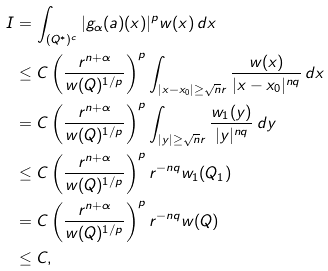<formula> <loc_0><loc_0><loc_500><loc_500>I & = \int _ { ( Q ^ { * } ) ^ { c } } | g _ { \alpha } ( a ) ( x ) | ^ { p } w ( x ) \, d x \\ & \leq C \left ( \frac { r ^ { n + \alpha } } { w ( Q ) ^ { 1 / p } } \right ) ^ { p } \int _ { | x - x _ { 0 } | \geq \sqrt { n } r } \frac { w ( x ) } { | x - x _ { 0 } | ^ { n q } } \, d x \\ & = C \left ( \frac { r ^ { n + \alpha } } { w ( Q ) ^ { 1 / p } } \right ) ^ { p } \int _ { | y | \geq \sqrt { n } r } \frac { w _ { 1 } ( y ) } { | y | ^ { n q } } \, d y \\ & \leq C \left ( \frac { r ^ { n + \alpha } } { w ( Q ) ^ { 1 / p } } \right ) ^ { p } r ^ { - n q } w _ { 1 } ( Q _ { 1 } ) \\ & = C \left ( \frac { r ^ { n + \alpha } } { w ( Q ) ^ { 1 / p } } \right ) ^ { p } r ^ { - n q } w ( Q ) \\ & \leq C ,</formula> 